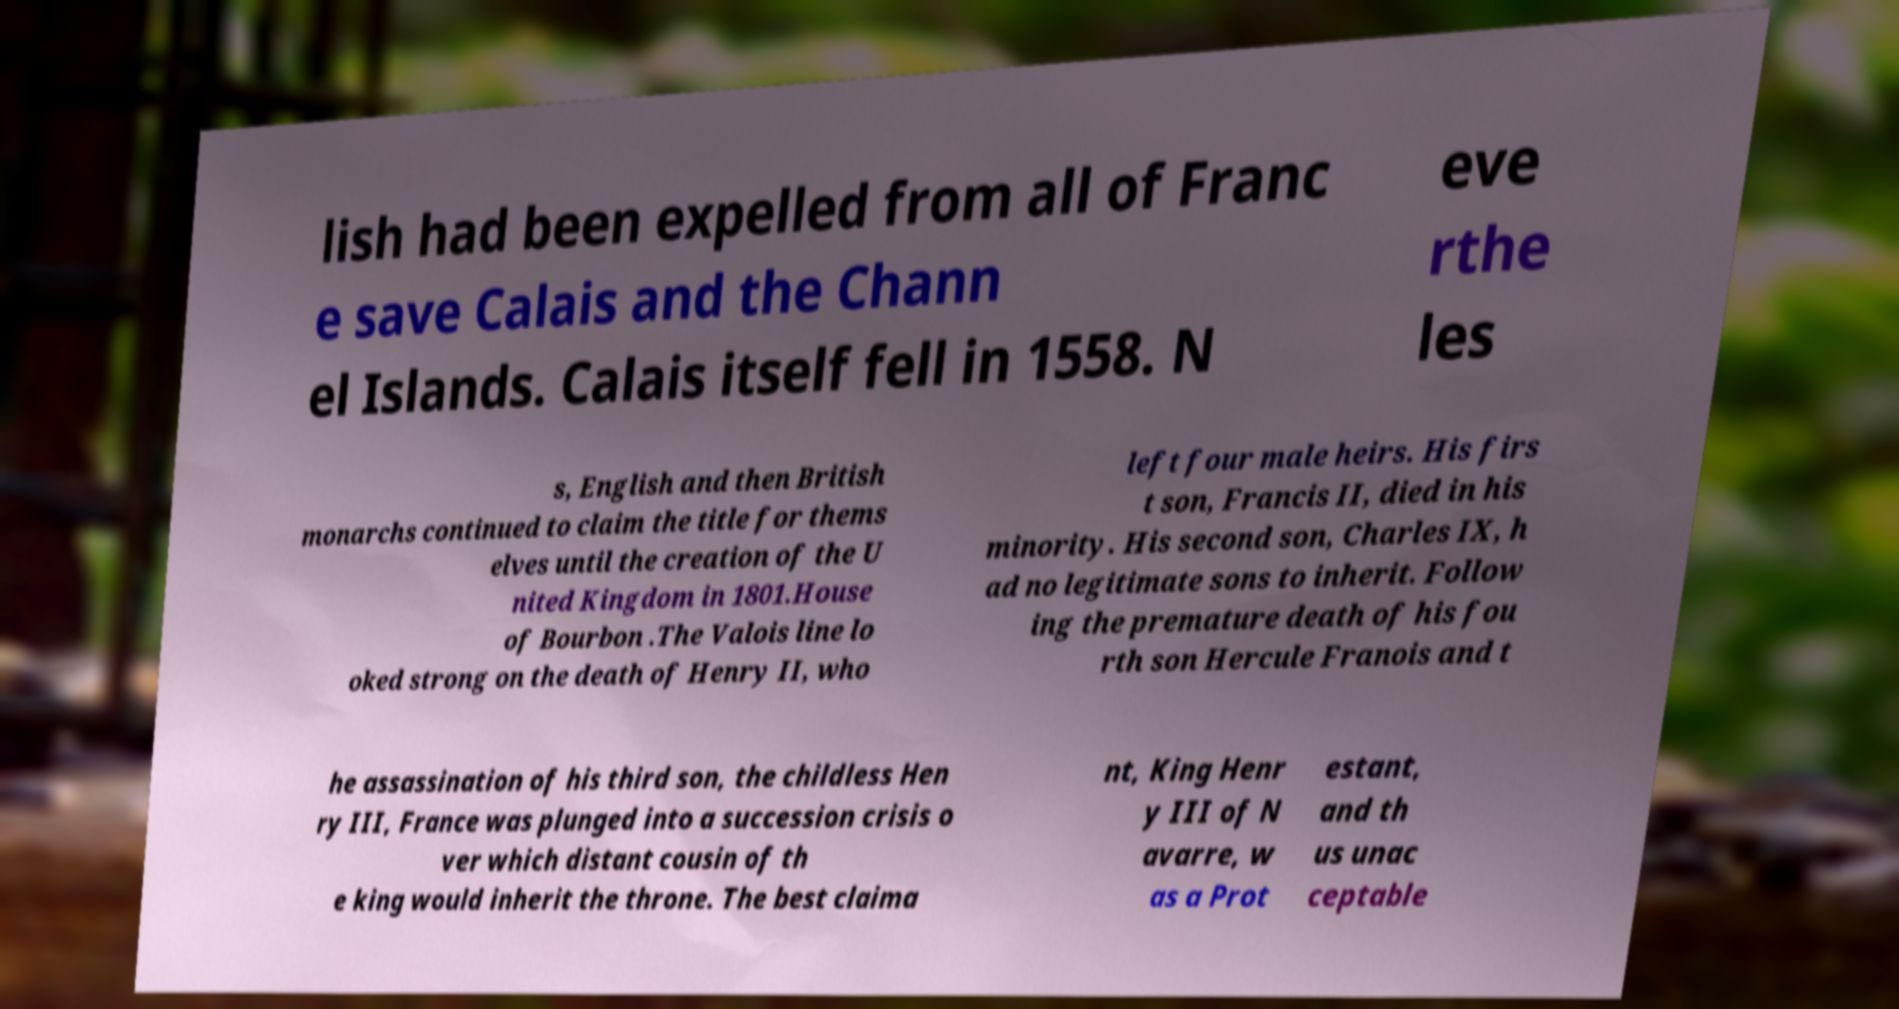I need the written content from this picture converted into text. Can you do that? lish had been expelled from all of Franc e save Calais and the Chann el Islands. Calais itself fell in 1558. N eve rthe les s, English and then British monarchs continued to claim the title for thems elves until the creation of the U nited Kingdom in 1801.House of Bourbon .The Valois line lo oked strong on the death of Henry II, who left four male heirs. His firs t son, Francis II, died in his minority. His second son, Charles IX, h ad no legitimate sons to inherit. Follow ing the premature death of his fou rth son Hercule Franois and t he assassination of his third son, the childless Hen ry III, France was plunged into a succession crisis o ver which distant cousin of th e king would inherit the throne. The best claima nt, King Henr y III of N avarre, w as a Prot estant, and th us unac ceptable 